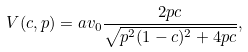Convert formula to latex. <formula><loc_0><loc_0><loc_500><loc_500>V ( c , p ) = a v _ { 0 } \frac { 2 p c } { \sqrt { p ^ { 2 } ( 1 - c ) ^ { 2 } + 4 p c } } ,</formula> 